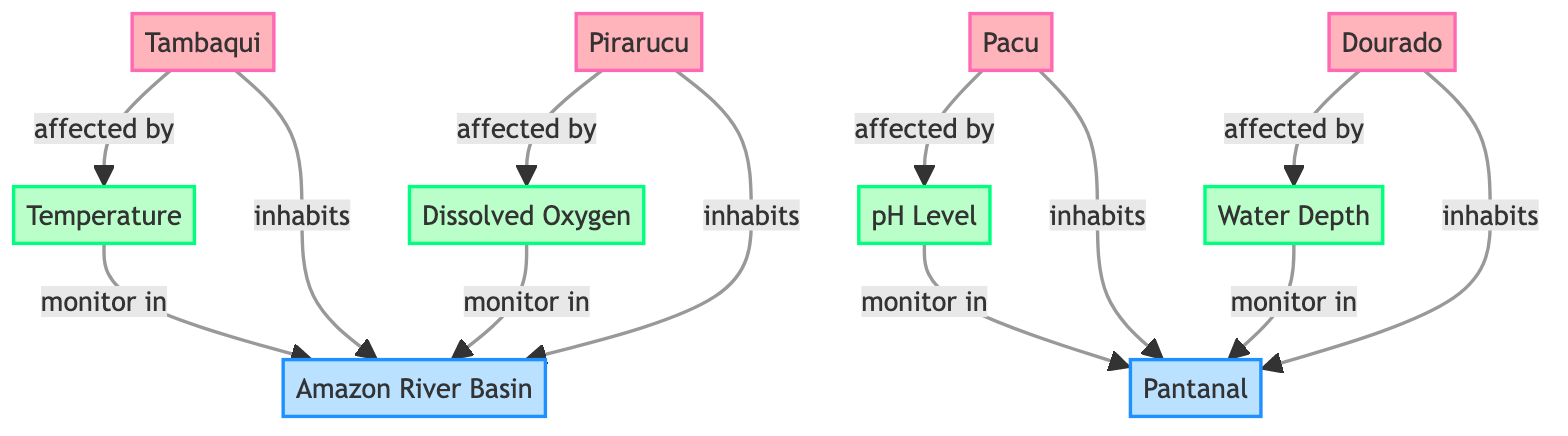What fish species is affected by temperature? The diagram shows an interaction where Tambaqui is connected to Temperature with the label "affected by." This indicates that Tambaqui is influenced by changes in temperature.
Answer: Tambaqui How many environmental factors are listed in the diagram? The diagram includes four environmental factors: Temperature, pH Level, Dissolved Oxygen, and Water Depth. By counting these nodes labeled as environmental factors, we find the total number.
Answer: 4 Which fish species inhabits the Amazon River Basin? The diagram shows Tambaqui and Pirarucu connected to the Amazon River Basin with the label "inhabits," indicating both species reside in this ecosystem location.
Answer: Tambaqui, Pirarucu What is the connection type between Pacu and pH Level? The interaction between Pacu and pH Level is described as "affected by," which indicates Pacu's life is influenced by the pH level of the water it inhabits.
Answer: affected by What environmental factors are monitored in the Pantanal? The diagram indicates that pH Level and Water Depth are monitored in the Pantanal, as shown by edges labeled "monitor in" connecting these environmental factors to the Pantanal node.
Answer: pH Level, Water Depth Which two fish species inhabit the Pantanal? In the diagram, only Pacu and Dourado are connected to the Pantanal with the "inhabits" label, indicating these species live in that ecosystem.
Answer: Pacu, Dourado How does dissolved oxygen affect Pirarucu? The diagram represents a direct interaction labeled "affected by" between Pirarucu and Dissolved Oxygen, indicating that Pirarucu's habitat or health is influenced by the levels of dissolved oxygen in the water.
Answer: affected by What is the total number of species and environmental factors depicted in the diagram? Counting the nodes, there are four fish species and four environmental factors. Adding these together provides the total number of distinct species and environmental influences.
Answer: 8 Which fish species is monitored in the Amazon River Basin? The connection between Dissolved Oxygen and the Amazon River Basin indicates that dissolved oxygen levels are a factor monitored within that ecosystem, specifically affecting the fish species residing there. the relevant fish species in this context is Pirarucu which is indicated to inhabit the Amazon River Basin.
Answer: Pirarucu 